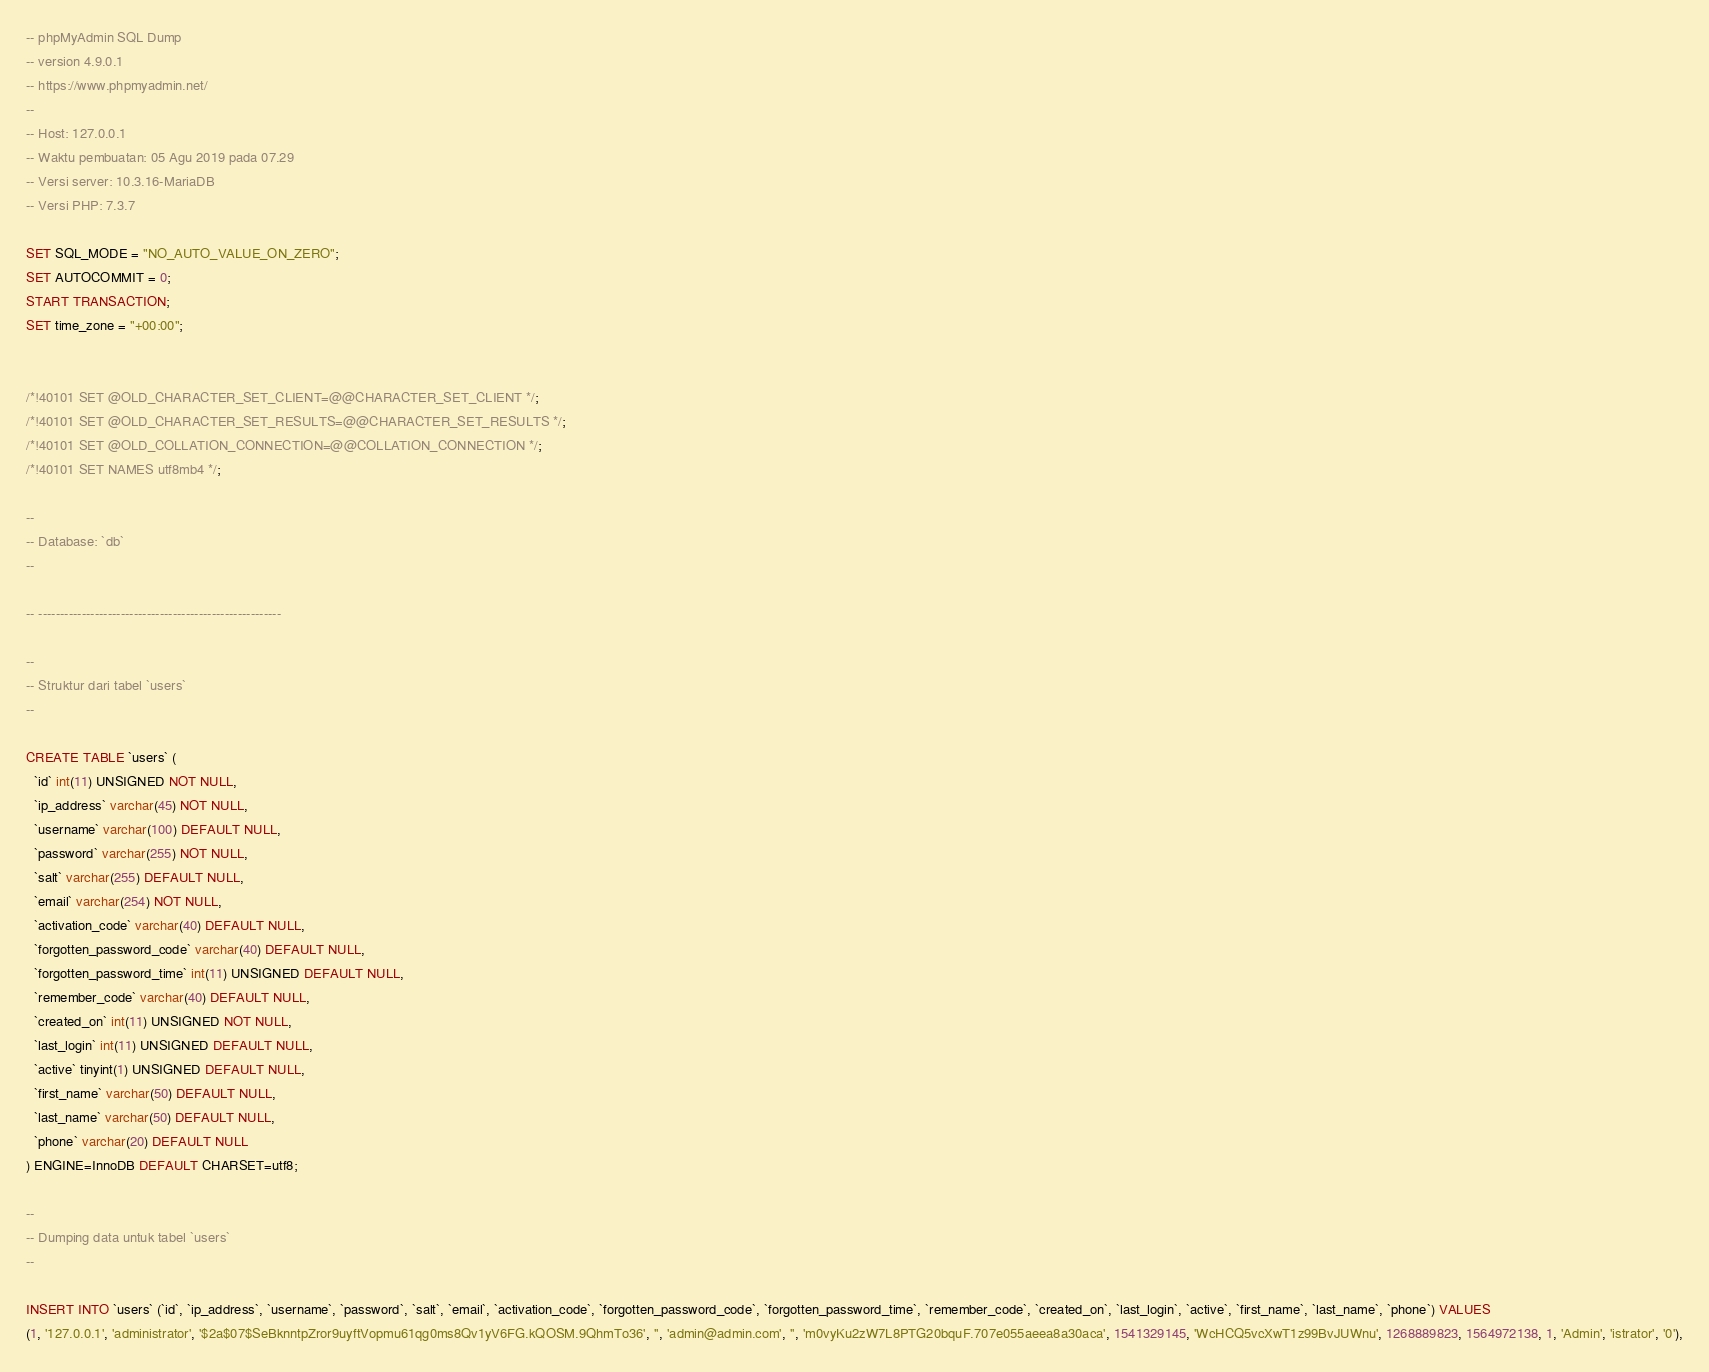<code> <loc_0><loc_0><loc_500><loc_500><_SQL_>-- phpMyAdmin SQL Dump
-- version 4.9.0.1
-- https://www.phpmyadmin.net/
--
-- Host: 127.0.0.1
-- Waktu pembuatan: 05 Agu 2019 pada 07.29
-- Versi server: 10.3.16-MariaDB
-- Versi PHP: 7.3.7

SET SQL_MODE = "NO_AUTO_VALUE_ON_ZERO";
SET AUTOCOMMIT = 0;
START TRANSACTION;
SET time_zone = "+00:00";


/*!40101 SET @OLD_CHARACTER_SET_CLIENT=@@CHARACTER_SET_CLIENT */;
/*!40101 SET @OLD_CHARACTER_SET_RESULTS=@@CHARACTER_SET_RESULTS */;
/*!40101 SET @OLD_COLLATION_CONNECTION=@@COLLATION_CONNECTION */;
/*!40101 SET NAMES utf8mb4 */;

--
-- Database: `db`
--

-- --------------------------------------------------------

--
-- Struktur dari tabel `users`
--

CREATE TABLE `users` (
  `id` int(11) UNSIGNED NOT NULL,
  `ip_address` varchar(45) NOT NULL,
  `username` varchar(100) DEFAULT NULL,
  `password` varchar(255) NOT NULL,
  `salt` varchar(255) DEFAULT NULL,
  `email` varchar(254) NOT NULL,
  `activation_code` varchar(40) DEFAULT NULL,
  `forgotten_password_code` varchar(40) DEFAULT NULL,
  `forgotten_password_time` int(11) UNSIGNED DEFAULT NULL,
  `remember_code` varchar(40) DEFAULT NULL,
  `created_on` int(11) UNSIGNED NOT NULL,
  `last_login` int(11) UNSIGNED DEFAULT NULL,
  `active` tinyint(1) UNSIGNED DEFAULT NULL,
  `first_name` varchar(50) DEFAULT NULL,
  `last_name` varchar(50) DEFAULT NULL,
  `phone` varchar(20) DEFAULT NULL
) ENGINE=InnoDB DEFAULT CHARSET=utf8;

--
-- Dumping data untuk tabel `users`
--

INSERT INTO `users` (`id`, `ip_address`, `username`, `password`, `salt`, `email`, `activation_code`, `forgotten_password_code`, `forgotten_password_time`, `remember_code`, `created_on`, `last_login`, `active`, `first_name`, `last_name`, `phone`) VALUES
(1, '127.0.0.1', 'administrator', '$2a$07$SeBknntpZror9uyftVopmu61qg0ms8Qv1yV6FG.kQOSM.9QhmTo36', '', 'admin@admin.com', '', 'm0vyKu2zW7L8PTG20bquF.707e055aeea8a30aca', 1541329145, 'WcHCQ5vcXwT1z99BvJUWnu', 1268889823, 1564972138, 1, 'Admin', 'istrator', '0'),</code> 